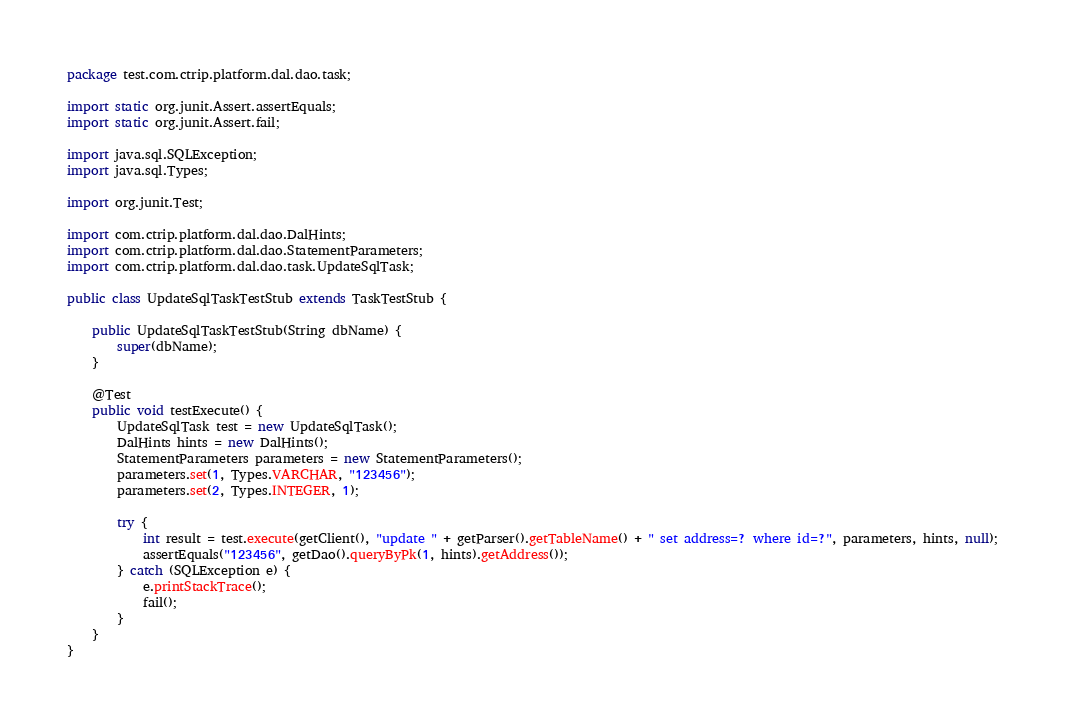Convert code to text. <code><loc_0><loc_0><loc_500><loc_500><_Java_>package test.com.ctrip.platform.dal.dao.task;

import static org.junit.Assert.assertEquals;
import static org.junit.Assert.fail;

import java.sql.SQLException;
import java.sql.Types;

import org.junit.Test;

import com.ctrip.platform.dal.dao.DalHints;
import com.ctrip.platform.dal.dao.StatementParameters;
import com.ctrip.platform.dal.dao.task.UpdateSqlTask;

public class UpdateSqlTaskTestStub extends TaskTestStub {
	
	public UpdateSqlTaskTestStub(String dbName) {
		super(dbName);
	}

	@Test
	public void testExecute() {
		UpdateSqlTask test = new UpdateSqlTask();
		DalHints hints = new DalHints();
		StatementParameters parameters = new StatementParameters();
		parameters.set(1, Types.VARCHAR, "123456");
		parameters.set(2, Types.INTEGER, 1);
		
		try {
			int result = test.execute(getClient(), "update " + getParser().getTableName() + " set address=? where id=?", parameters, hints, null);
			assertEquals("123456", getDao().queryByPk(1, hints).getAddress());
		} catch (SQLException e) {
			e.printStackTrace();
			fail();
		}
	}
}
</code> 